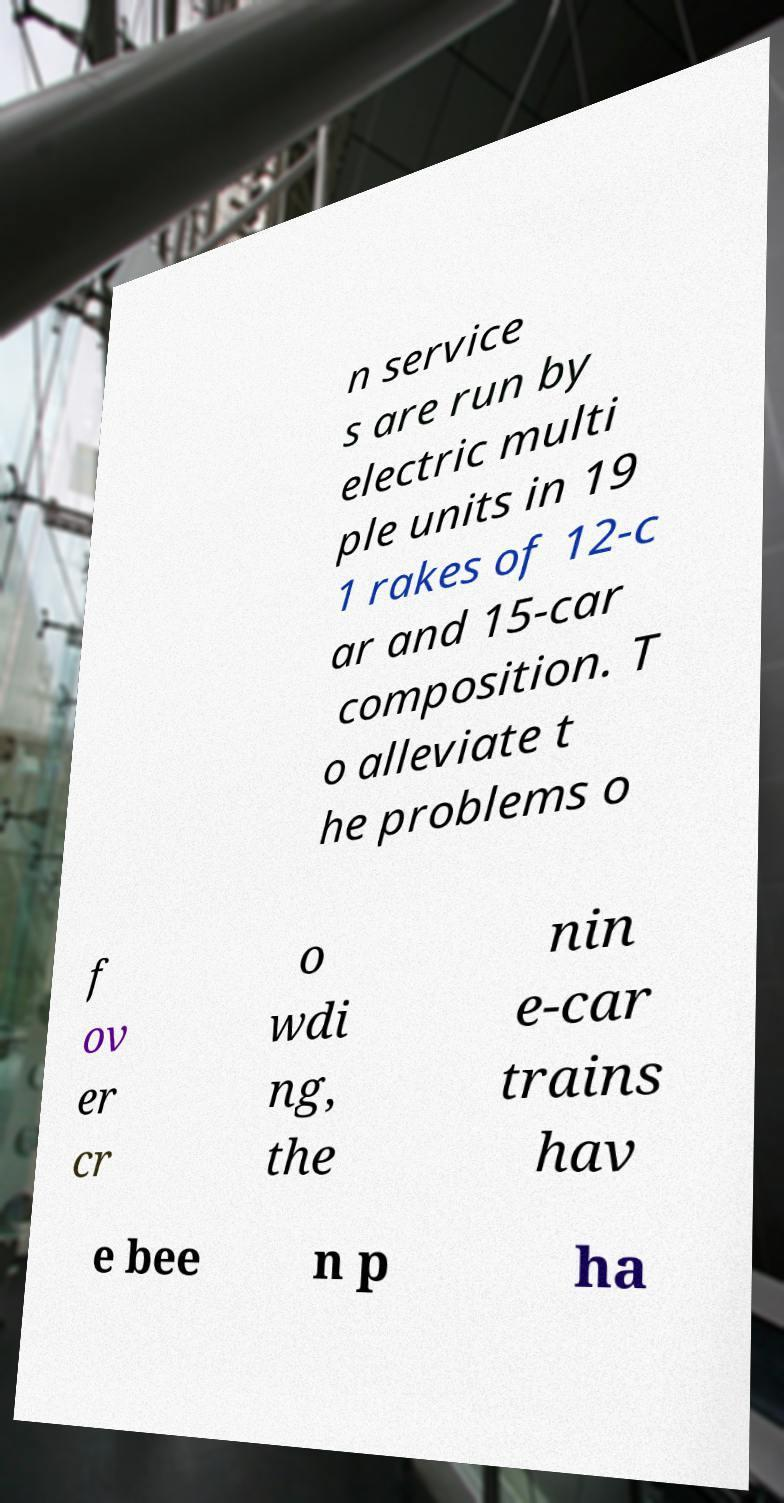Can you read and provide the text displayed in the image?This photo seems to have some interesting text. Can you extract and type it out for me? n service s are run by electric multi ple units in 19 1 rakes of 12-c ar and 15-car composition. T o alleviate t he problems o f ov er cr o wdi ng, the nin e-car trains hav e bee n p ha 